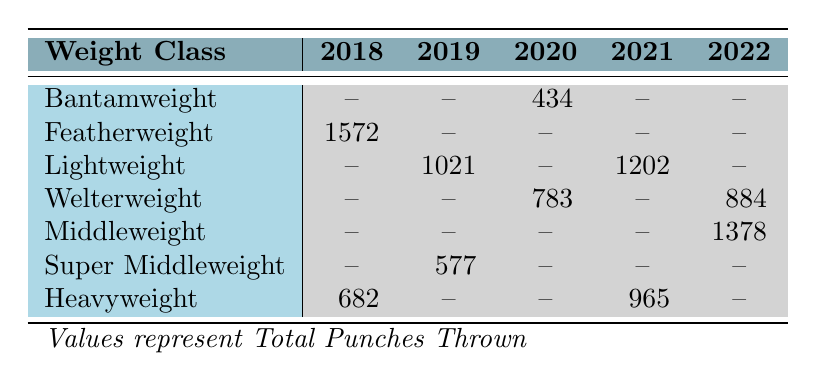What was the highest number of total punches thrown in a single match across all years? By scanning the column of total punches thrown for each weight class and year, we compare the maximum values: 1572 for Featherweight in 2018, and 1378 for Middleweight in 2022. The maximum is 1572 punches.
Answer: 1572 Which weight class had matches recorded in all five years? By examining the table, the Lightweight category is the only one that appears in both 2019 and 2021, while the other weight classes either have no entries or only partial years represented.
Answer: No How many total punches were thrown in the Lightweight class across the years it was represented (2019 and 2021)? The total punches thrown for the Lightweight class in the available years is 1021 (2019) + 1202 (2021) = 2223.
Answer: 2223 How many matches resulted in a decision that was a knockout (KO)? A review of the decision column reveals a KO in 2021 (Fury vs. Wilder III) and 2019 (Canelo vs. Kovalev). Therefore, there are two matches that concluded by knockout.
Answer: 2 Did any Bantamweight matches take place in 2018? The table indicates that there is an entry for Bantamweight in the year 2020 only, and the entry for 2018 shows no matches in that weight classification.
Answer: No What is the average number of total punches thrown in the Heavyweight class matches? Summing the punches thrown in the Heavyweight class for the two years gives us: 682 (2018) + 965 (2021) = 1647. Dividing by 2 (the number of matches) results in an average of 823.5 total punches thrown.
Answer: 823.5 Which weight class had the highest total punches landed in one match? By comparing the total punches landed statistics, it is noted that the Lightweight match in 2019 registered 311 punches landed while the Featherweight in 2018 had 371 punches landed. Thus, the Featherweight class had the highest.
Answer: Featherweight How many rounds did the Welterweight matches span across their recorded years? The Welterweight matches occurred in 2020 (12 rounds) and in 2022 (10 rounds). Summing these yields a total of 22 rounds across both matches.
Answer: 22 